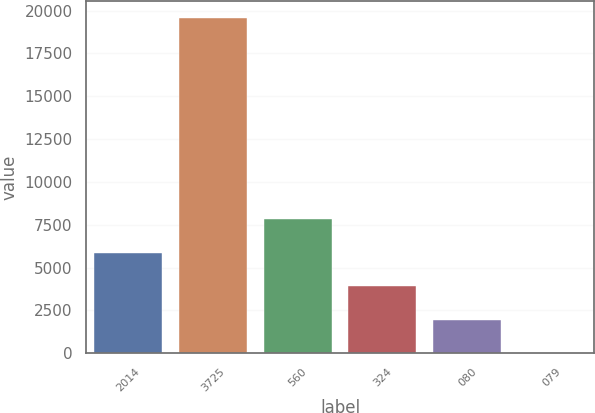Convert chart to OTSL. <chart><loc_0><loc_0><loc_500><loc_500><bar_chart><fcel>2014<fcel>3725<fcel>560<fcel>324<fcel>080<fcel>079<nl><fcel>5872.54<fcel>19566<fcel>7828.75<fcel>3916.33<fcel>1960.12<fcel>3.91<nl></chart> 